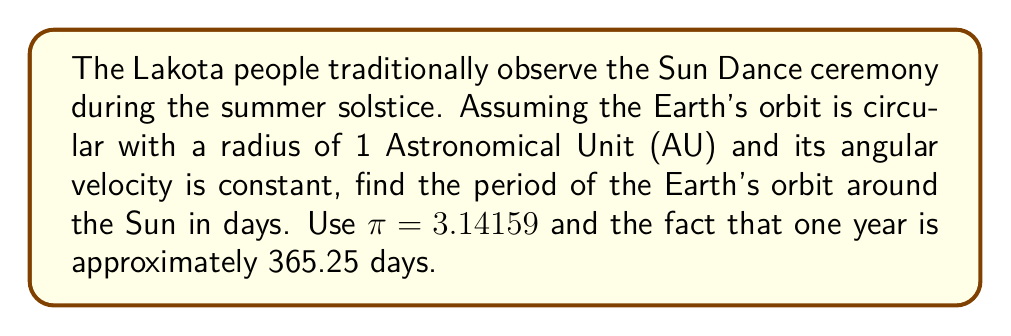Could you help me with this problem? Let's approach this step-by-step:

1) In a circular orbit, the angular velocity $\omega$ is constant and related to the period $T$ by:

   $$\omega = \frac{2\pi}{T}$$

2) We know that one complete orbit (2π radians) takes 365.25 days. So:

   $$\frac{2\pi}{T} = \frac{2\pi}{365.25 \text{ days}}$$

3) Simplify by canceling 2π on both sides:

   $$\frac{1}{T} = \frac{1}{365.25 \text{ days}}$$

4) Therefore:

   $$T = 365.25 \text{ days}$$

5) To verify, we can calculate the angular velocity:

   $$\omega = \frac{2\pi}{365.25 \text{ days}} \approx 0.0172 \text{ radians/day}$$

6) In one day, the Earth travels:

   $$0.0172 \cdot \frac{180^\circ}{\pi} \approx 0.9856^\circ$$

   This is close to the commonly cited value of the Earth's daily motion of about 1° per day.

The period of 365.25 days represents the time between successive summer solstices, which is important for timing the Sun Dance ceremony in Lakota tradition.
Answer: 365.25 days 